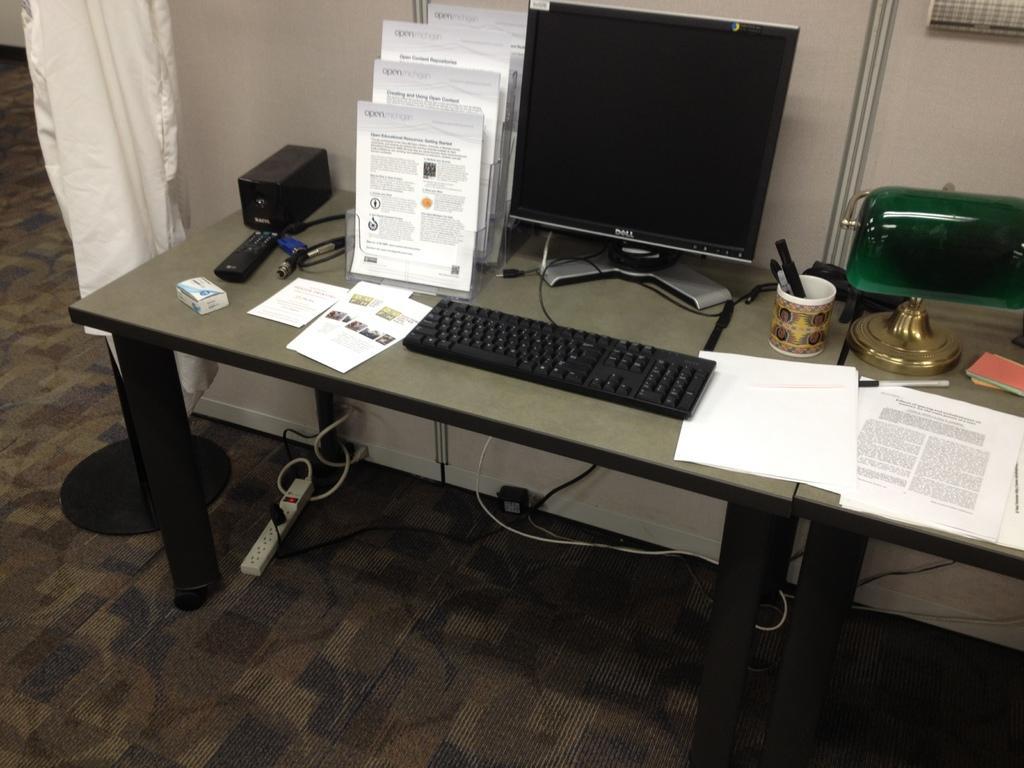How would you summarize this image in a sentence or two? In this image there are books, a computer, keyboard, papers and some other objects on the table, there are cables and a plug box on the floor, there is a curtain beside the table. 